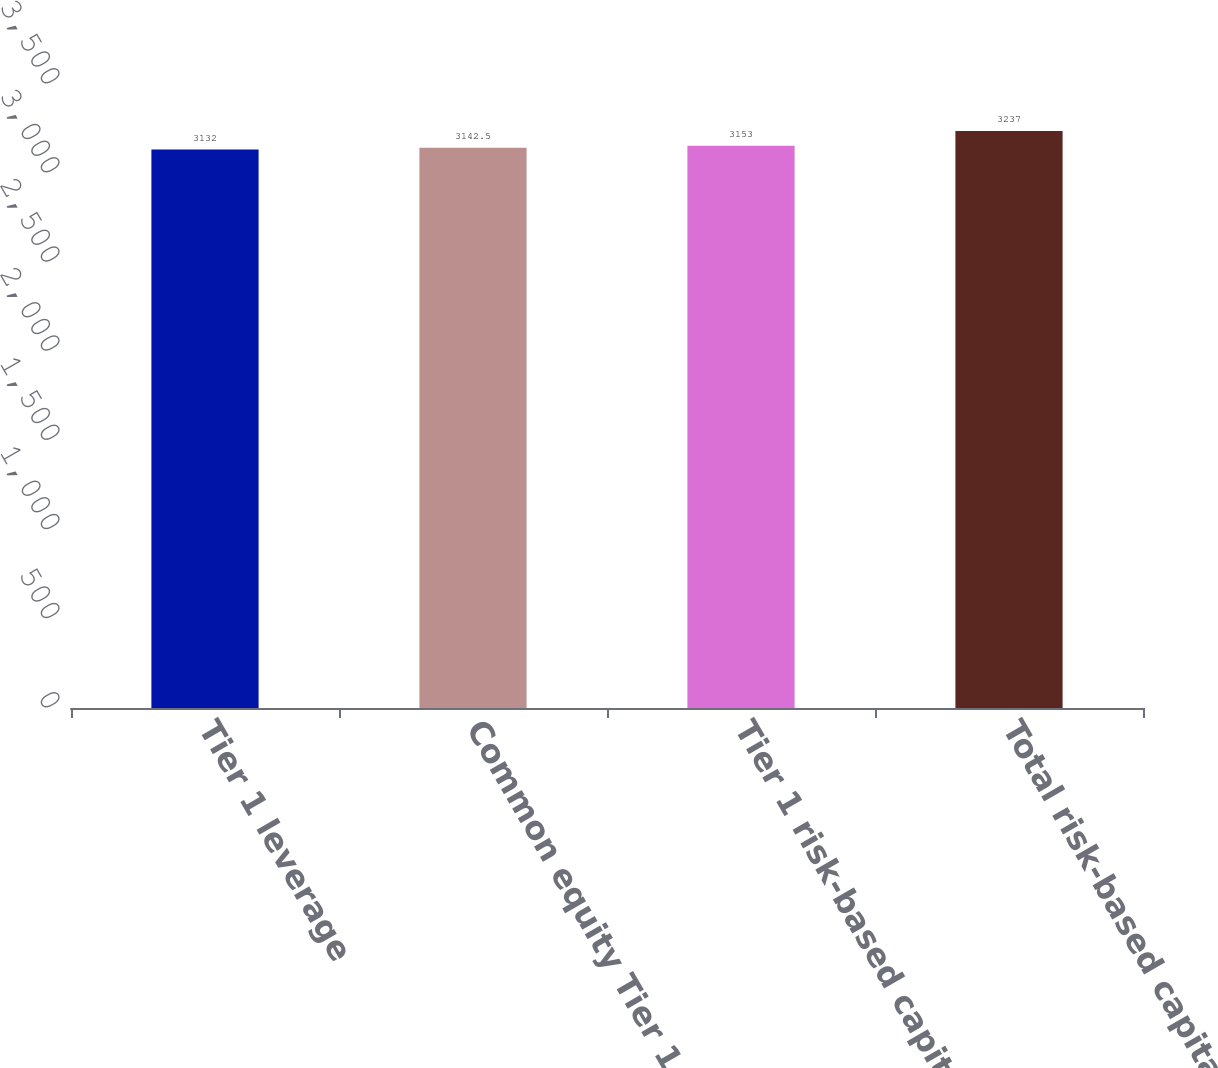<chart> <loc_0><loc_0><loc_500><loc_500><bar_chart><fcel>Tier 1 leverage<fcel>Common equity Tier 1 capital<fcel>Tier 1 risk-based capital<fcel>Total risk-based capital<nl><fcel>3132<fcel>3142.5<fcel>3153<fcel>3237<nl></chart> 